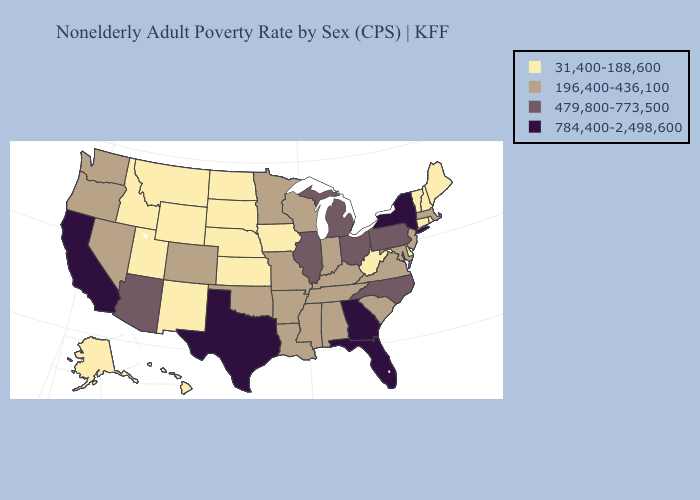Among the states that border Tennessee , does Georgia have the highest value?
Concise answer only. Yes. What is the lowest value in the USA?
Write a very short answer. 31,400-188,600. Name the states that have a value in the range 784,400-2,498,600?
Short answer required. California, Florida, Georgia, New York, Texas. Name the states that have a value in the range 479,800-773,500?
Keep it brief. Arizona, Illinois, Michigan, North Carolina, Ohio, Pennsylvania. What is the highest value in the USA?
Concise answer only. 784,400-2,498,600. What is the value of Arizona?
Concise answer only. 479,800-773,500. Which states hav the highest value in the Northeast?
Give a very brief answer. New York. Name the states that have a value in the range 31,400-188,600?
Be succinct. Alaska, Connecticut, Delaware, Hawaii, Idaho, Iowa, Kansas, Maine, Montana, Nebraska, New Hampshire, New Mexico, North Dakota, Rhode Island, South Dakota, Utah, Vermont, West Virginia, Wyoming. Name the states that have a value in the range 784,400-2,498,600?
Answer briefly. California, Florida, Georgia, New York, Texas. What is the value of West Virginia?
Answer briefly. 31,400-188,600. What is the lowest value in states that border New York?
Keep it brief. 31,400-188,600. What is the highest value in the West ?
Give a very brief answer. 784,400-2,498,600. What is the value of Michigan?
Give a very brief answer. 479,800-773,500. Among the states that border Wyoming , which have the highest value?
Quick response, please. Colorado. Is the legend a continuous bar?
Be succinct. No. 